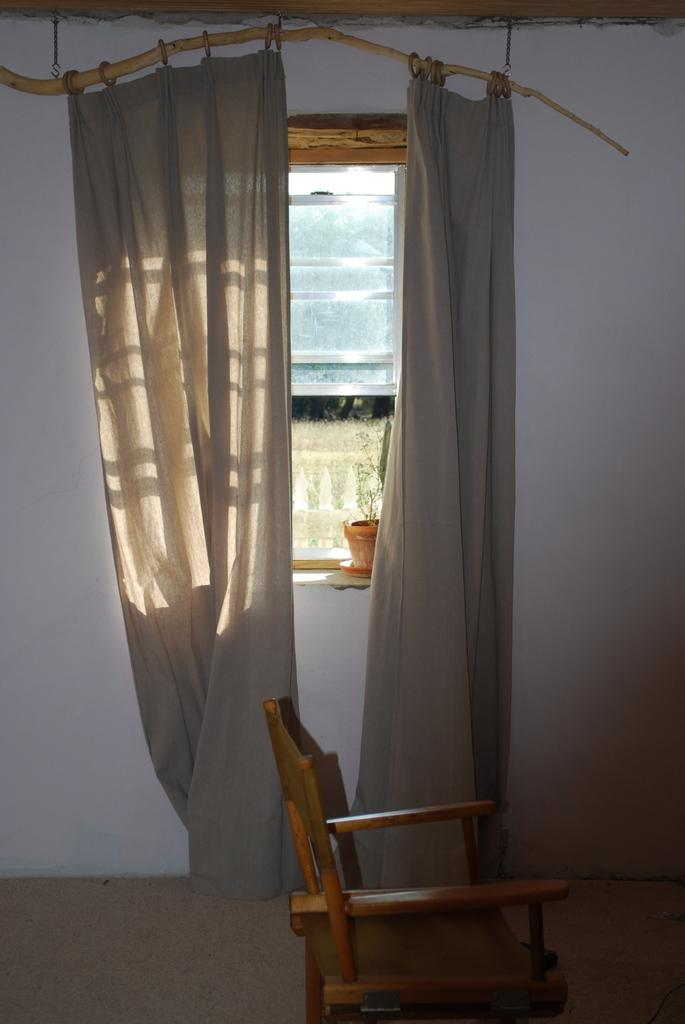What type of window is present in the image? There is a glass window in the image. What can be seen below the window in the image? The ground is visible in the image. What type of furniture is in the image? There is a chair in the image. What is located near the window in the image? There is a pot in the image. What type of window treatment is present in the image? There are curtains on a pole in the image. How many planes can be seen flying in the image? There are no planes visible in the image. What grade is the student receiving in the image? There is no student or grade present in the image. 